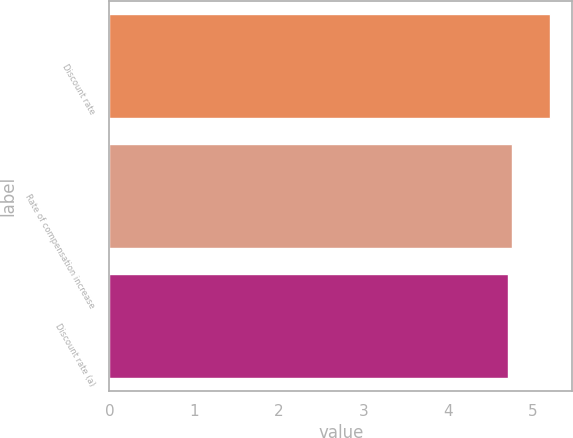Convert chart to OTSL. <chart><loc_0><loc_0><loc_500><loc_500><bar_chart><fcel>Discount rate<fcel>Rate of compensation increase<fcel>Discount rate (a)<nl><fcel>5.2<fcel>4.75<fcel>4.7<nl></chart> 